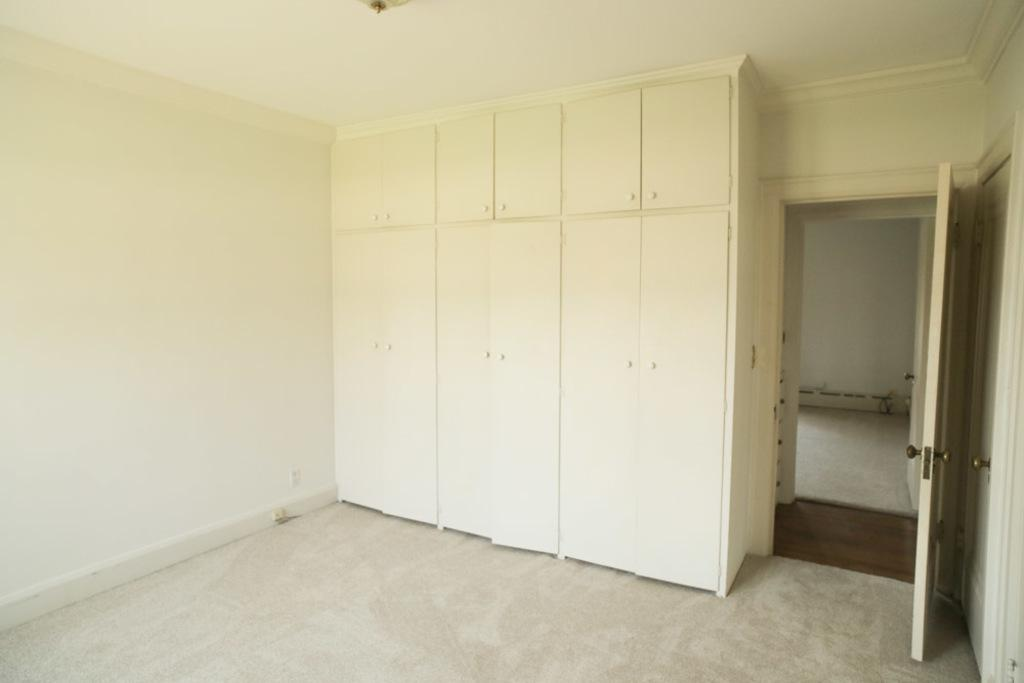What type of furniture is present in the image? There are cupboards in the image. What architectural features can be seen in the image? There are doors, a wall, and a roof visible in the image. What part of the structure is visible at the bottom of the image? The ground is visible in the image. Can you see any celery being stitched in the image? There is no celery or stitching present in the image. Is anyone swimming in the image? There is no swimming depicted in the image. 